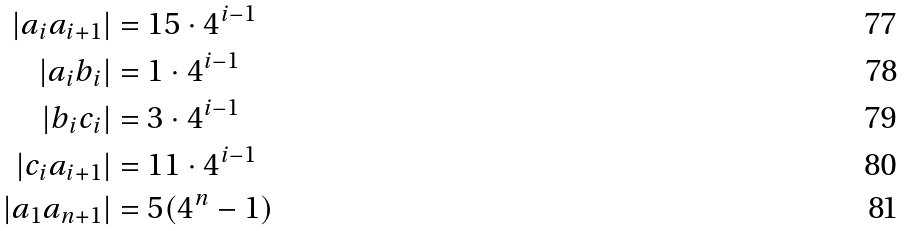Convert formula to latex. <formula><loc_0><loc_0><loc_500><loc_500>| a _ { i } a _ { i + 1 } | & = 1 5 \cdot 4 ^ { i - 1 } \\ | a _ { i } b _ { i } | & = 1 \cdot 4 ^ { i - 1 } \\ | b _ { i } c _ { i } | & = 3 \cdot 4 ^ { i - 1 } \\ | c _ { i } a _ { i + 1 } | & = 1 1 \cdot 4 ^ { i - 1 } \\ | a _ { 1 } a _ { n + 1 } | & = 5 ( 4 ^ { n } - 1 )</formula> 